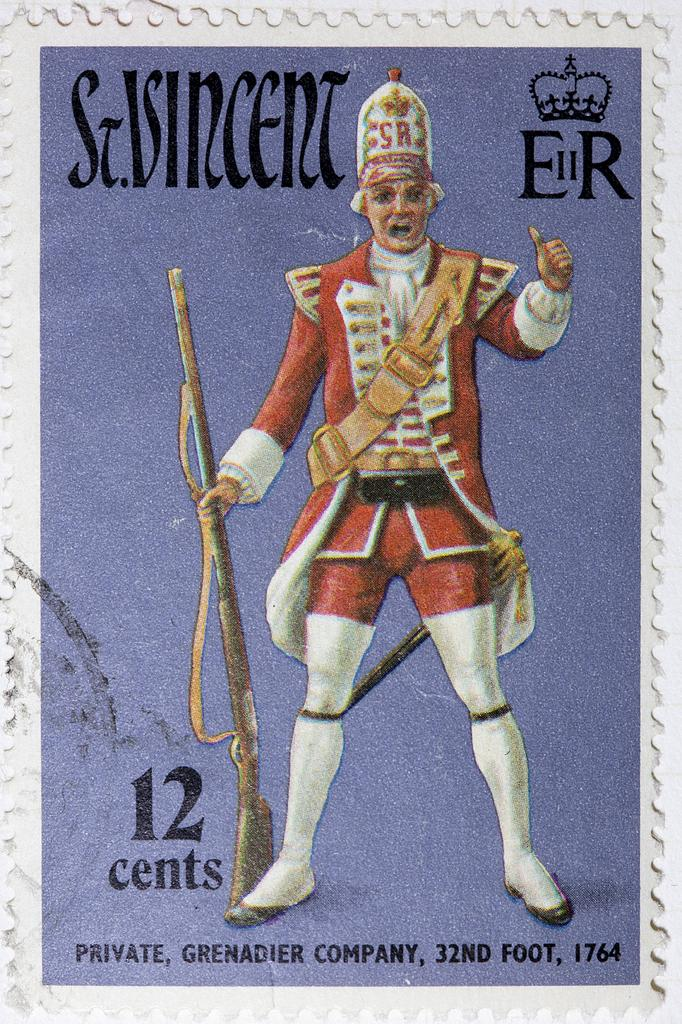What is the main subject of the poster in the image? The main subject of the poster in the image is a person. What is the person doing in the poster? The person is wearing different costumes and holding a gun in their hands. Is there any text on the poster? Yes, there is text written on the poster. What is the weight of the clocks on the floor in the image? There are no clocks or floors present in the image; it features a poster with a person wearing different costumes and holding a gun. 